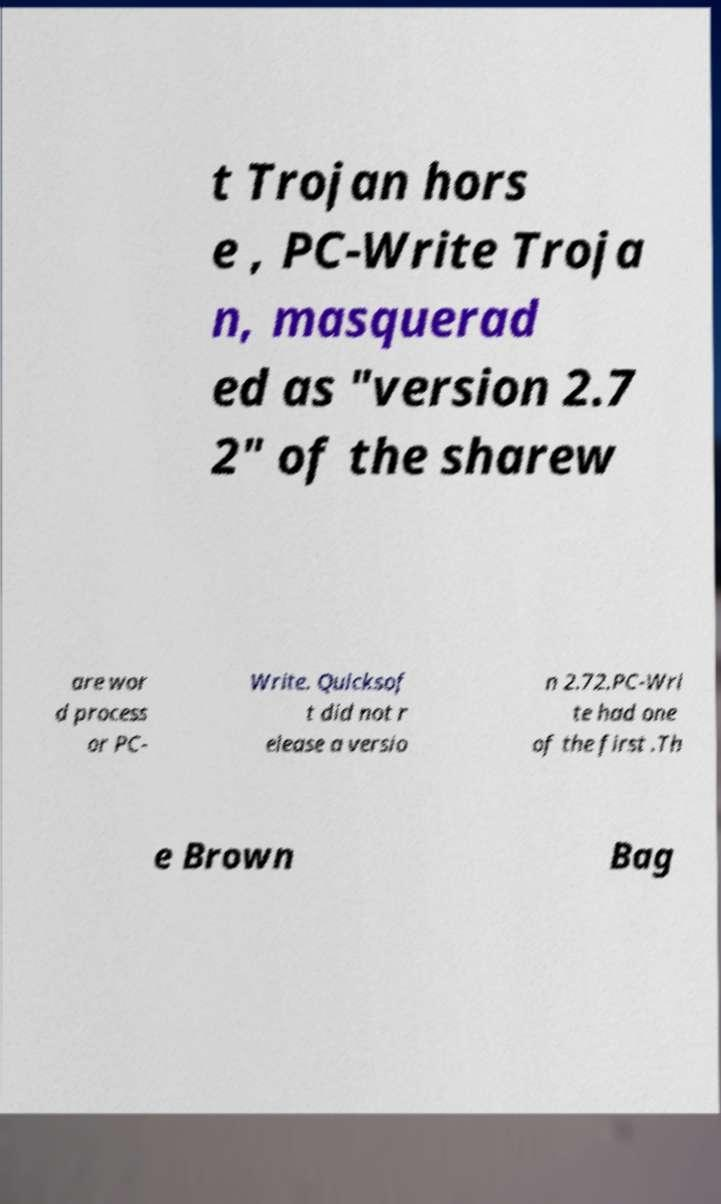Could you assist in decoding the text presented in this image and type it out clearly? t Trojan hors e , PC-Write Troja n, masquerad ed as "version 2.7 2" of the sharew are wor d process or PC- Write. Quicksof t did not r elease a versio n 2.72.PC-Wri te had one of the first .Th e Brown Bag 